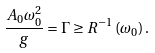<formula> <loc_0><loc_0><loc_500><loc_500>\frac { A _ { 0 } \omega _ { 0 } ^ { 2 } } { g } = \Gamma \geq R ^ { - 1 } \left ( \omega _ { 0 } \right ) .</formula> 